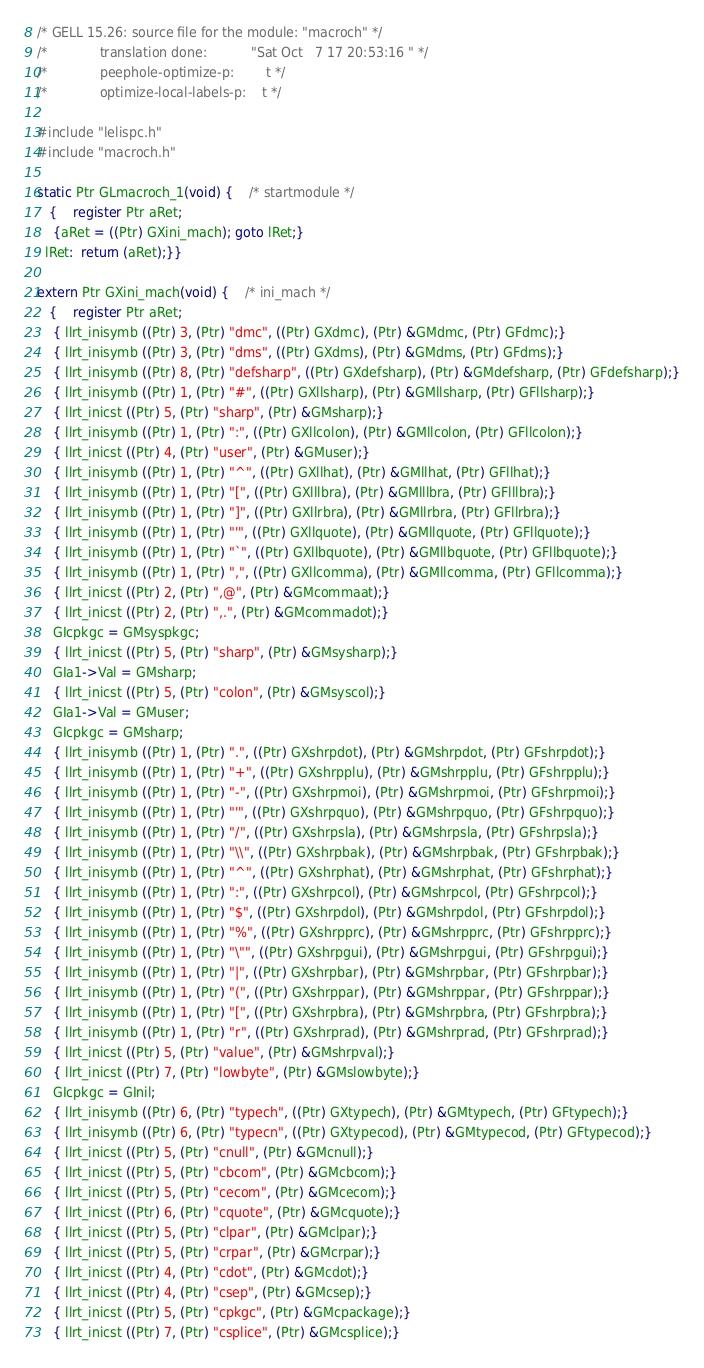<code> <loc_0><loc_0><loc_500><loc_500><_C_>/* GELL 15.26: source file for the module: "macroch" */
/*             translation done:           "Sat Oct   7 17 20:53:16 " */
/*             peephole-optimize-p:        t */
/*             optimize-local-labels-p:    t */

#include "lelispc.h" 
#include "macroch.h" 

static Ptr GLmacroch_1(void) {	/* startmodule */
   {	register Ptr aRet;
	{aRet = ((Ptr) GXini_mach); goto lRet;}
  lRet:  return (aRet);}}

extern Ptr GXini_mach(void) {	/* ini_mach */
   {	register Ptr aRet;
	{ llrt_inisymb ((Ptr) 3, (Ptr) "dmc", ((Ptr) GXdmc), (Ptr) &GMdmc, (Ptr) GFdmc);}
	{ llrt_inisymb ((Ptr) 3, (Ptr) "dms", ((Ptr) GXdms), (Ptr) &GMdms, (Ptr) GFdms);}
	{ llrt_inisymb ((Ptr) 8, (Ptr) "defsharp", ((Ptr) GXdefsharp), (Ptr) &GMdefsharp, (Ptr) GFdefsharp);}
	{ llrt_inisymb ((Ptr) 1, (Ptr) "#", ((Ptr) GXllsharp), (Ptr) &GMllsharp, (Ptr) GFllsharp);}
	{ llrt_inicst ((Ptr) 5, (Ptr) "sharp", (Ptr) &GMsharp);}
	{ llrt_inisymb ((Ptr) 1, (Ptr) ":", ((Ptr) GXllcolon), (Ptr) &GMllcolon, (Ptr) GFllcolon);}
	{ llrt_inicst ((Ptr) 4, (Ptr) "user", (Ptr) &GMuser);}
	{ llrt_inisymb ((Ptr) 1, (Ptr) "^", ((Ptr) GXllhat), (Ptr) &GMllhat, (Ptr) GFllhat);}
	{ llrt_inisymb ((Ptr) 1, (Ptr) "[", ((Ptr) GXlllbra), (Ptr) &GMlllbra, (Ptr) GFlllbra);}
	{ llrt_inisymb ((Ptr) 1, (Ptr) "]", ((Ptr) GXllrbra), (Ptr) &GMllrbra, (Ptr) GFllrbra);}
	{ llrt_inisymb ((Ptr) 1, (Ptr) "'", ((Ptr) GXllquote), (Ptr) &GMllquote, (Ptr) GFllquote);}
	{ llrt_inisymb ((Ptr) 1, (Ptr) "`", ((Ptr) GXllbquote), (Ptr) &GMllbquote, (Ptr) GFllbquote);}
	{ llrt_inisymb ((Ptr) 1, (Ptr) ",", ((Ptr) GXllcomma), (Ptr) &GMllcomma, (Ptr) GFllcomma);}
	{ llrt_inicst ((Ptr) 2, (Ptr) ",@", (Ptr) &GMcommaat);}
	{ llrt_inicst ((Ptr) 2, (Ptr) ",.", (Ptr) &GMcommadot);}
	GIcpkgc = GMsyspkgc;
	{ llrt_inicst ((Ptr) 5, (Ptr) "sharp", (Ptr) &GMsysharp);}
	GIa1->Val = GMsharp;
	{ llrt_inicst ((Ptr) 5, (Ptr) "colon", (Ptr) &GMsyscol);}
	GIa1->Val = GMuser;
	GIcpkgc = GMsharp;
	{ llrt_inisymb ((Ptr) 1, (Ptr) ".", ((Ptr) GXshrpdot), (Ptr) &GMshrpdot, (Ptr) GFshrpdot);}
	{ llrt_inisymb ((Ptr) 1, (Ptr) "+", ((Ptr) GXshrpplu), (Ptr) &GMshrpplu, (Ptr) GFshrpplu);}
	{ llrt_inisymb ((Ptr) 1, (Ptr) "-", ((Ptr) GXshrpmoi), (Ptr) &GMshrpmoi, (Ptr) GFshrpmoi);}
	{ llrt_inisymb ((Ptr) 1, (Ptr) "'", ((Ptr) GXshrpquo), (Ptr) &GMshrpquo, (Ptr) GFshrpquo);}
	{ llrt_inisymb ((Ptr) 1, (Ptr) "/", ((Ptr) GXshrpsla), (Ptr) &GMshrpsla, (Ptr) GFshrpsla);}
	{ llrt_inisymb ((Ptr) 1, (Ptr) "\\", ((Ptr) GXshrpbak), (Ptr) &GMshrpbak, (Ptr) GFshrpbak);}
	{ llrt_inisymb ((Ptr) 1, (Ptr) "^", ((Ptr) GXshrphat), (Ptr) &GMshrphat, (Ptr) GFshrphat);}
	{ llrt_inisymb ((Ptr) 1, (Ptr) ":", ((Ptr) GXshrpcol), (Ptr) &GMshrpcol, (Ptr) GFshrpcol);}
	{ llrt_inisymb ((Ptr) 1, (Ptr) "$", ((Ptr) GXshrpdol), (Ptr) &GMshrpdol, (Ptr) GFshrpdol);}
	{ llrt_inisymb ((Ptr) 1, (Ptr) "%", ((Ptr) GXshrpprc), (Ptr) &GMshrpprc, (Ptr) GFshrpprc);}
	{ llrt_inisymb ((Ptr) 1, (Ptr) "\"", ((Ptr) GXshrpgui), (Ptr) &GMshrpgui, (Ptr) GFshrpgui);}
	{ llrt_inisymb ((Ptr) 1, (Ptr) "|", ((Ptr) GXshrpbar), (Ptr) &GMshrpbar, (Ptr) GFshrpbar);}
	{ llrt_inisymb ((Ptr) 1, (Ptr) "(", ((Ptr) GXshrppar), (Ptr) &GMshrppar, (Ptr) GFshrppar);}
	{ llrt_inisymb ((Ptr) 1, (Ptr) "[", ((Ptr) GXshrpbra), (Ptr) &GMshrpbra, (Ptr) GFshrpbra);}
	{ llrt_inisymb ((Ptr) 1, (Ptr) "r", ((Ptr) GXshrprad), (Ptr) &GMshrprad, (Ptr) GFshrprad);}
	{ llrt_inicst ((Ptr) 5, (Ptr) "value", (Ptr) &GMshrpval);}
	{ llrt_inicst ((Ptr) 7, (Ptr) "lowbyte", (Ptr) &GMslowbyte);}
	GIcpkgc = GInil;
	{ llrt_inisymb ((Ptr) 6, (Ptr) "typech", ((Ptr) GXtypech), (Ptr) &GMtypech, (Ptr) GFtypech);}
	{ llrt_inisymb ((Ptr) 6, (Ptr) "typecn", ((Ptr) GXtypecod), (Ptr) &GMtypecod, (Ptr) GFtypecod);}
	{ llrt_inicst ((Ptr) 5, (Ptr) "cnull", (Ptr) &GMcnull);}
	{ llrt_inicst ((Ptr) 5, (Ptr) "cbcom", (Ptr) &GMcbcom);}
	{ llrt_inicst ((Ptr) 5, (Ptr) "cecom", (Ptr) &GMcecom);}
	{ llrt_inicst ((Ptr) 6, (Ptr) "cquote", (Ptr) &GMcquote);}
	{ llrt_inicst ((Ptr) 5, (Ptr) "clpar", (Ptr) &GMclpar);}
	{ llrt_inicst ((Ptr) 5, (Ptr) "crpar", (Ptr) &GMcrpar);}
	{ llrt_inicst ((Ptr) 4, (Ptr) "cdot", (Ptr) &GMcdot);}
	{ llrt_inicst ((Ptr) 4, (Ptr) "csep", (Ptr) &GMcsep);}
	{ llrt_inicst ((Ptr) 5, (Ptr) "cpkgc", (Ptr) &GMcpackage);}
	{ llrt_inicst ((Ptr) 7, (Ptr) "csplice", (Ptr) &GMcsplice);}</code> 